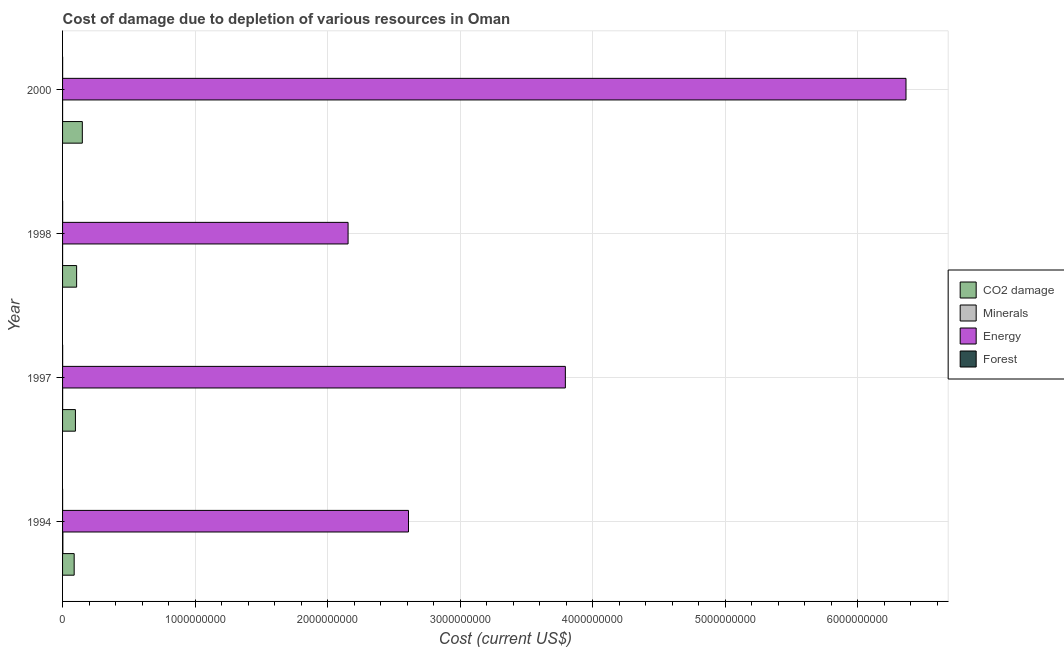How many groups of bars are there?
Make the answer very short. 4. Are the number of bars per tick equal to the number of legend labels?
Your answer should be compact. Yes. Are the number of bars on each tick of the Y-axis equal?
Provide a short and direct response. Yes. How many bars are there on the 3rd tick from the bottom?
Offer a very short reply. 4. In how many cases, is the number of bars for a given year not equal to the number of legend labels?
Ensure brevity in your answer.  0. What is the cost of damage due to depletion of minerals in 2000?
Keep it short and to the point. 4.51e+04. Across all years, what is the maximum cost of damage due to depletion of coal?
Provide a succinct answer. 1.49e+08. Across all years, what is the minimum cost of damage due to depletion of coal?
Provide a short and direct response. 8.76e+07. In which year was the cost of damage due to depletion of coal maximum?
Your answer should be compact. 2000. What is the total cost of damage due to depletion of minerals in the graph?
Give a very brief answer. 3.04e+06. What is the difference between the cost of damage due to depletion of minerals in 1997 and that in 2000?
Give a very brief answer. 4.32e+05. What is the difference between the cost of damage due to depletion of minerals in 2000 and the cost of damage due to depletion of coal in 1997?
Offer a very short reply. -9.70e+07. What is the average cost of damage due to depletion of forests per year?
Your answer should be compact. 4.68e+05. In the year 1994, what is the difference between the cost of damage due to depletion of energy and cost of damage due to depletion of forests?
Provide a succinct answer. 2.61e+09. What is the ratio of the cost of damage due to depletion of energy in 1997 to that in 1998?
Your response must be concise. 1.76. What is the difference between the highest and the second highest cost of damage due to depletion of energy?
Offer a very short reply. 2.57e+09. What is the difference between the highest and the lowest cost of damage due to depletion of forests?
Your answer should be compact. 1.61e+05. Is it the case that in every year, the sum of the cost of damage due to depletion of energy and cost of damage due to depletion of forests is greater than the sum of cost of damage due to depletion of minerals and cost of damage due to depletion of coal?
Your answer should be very brief. No. What does the 1st bar from the top in 1994 represents?
Provide a succinct answer. Forest. What does the 1st bar from the bottom in 1997 represents?
Your answer should be very brief. CO2 damage. Is it the case that in every year, the sum of the cost of damage due to depletion of coal and cost of damage due to depletion of minerals is greater than the cost of damage due to depletion of energy?
Provide a succinct answer. No. How many bars are there?
Ensure brevity in your answer.  16. Are all the bars in the graph horizontal?
Provide a succinct answer. Yes. How many years are there in the graph?
Your answer should be very brief. 4. What is the difference between two consecutive major ticks on the X-axis?
Keep it short and to the point. 1.00e+09. Are the values on the major ticks of X-axis written in scientific E-notation?
Make the answer very short. No. Does the graph contain any zero values?
Give a very brief answer. No. Does the graph contain grids?
Provide a short and direct response. Yes. How many legend labels are there?
Provide a short and direct response. 4. How are the legend labels stacked?
Keep it short and to the point. Vertical. What is the title of the graph?
Your response must be concise. Cost of damage due to depletion of various resources in Oman . Does "Secondary vocational" appear as one of the legend labels in the graph?
Keep it short and to the point. No. What is the label or title of the X-axis?
Provide a succinct answer. Cost (current US$). What is the Cost (current US$) of CO2 damage in 1994?
Ensure brevity in your answer.  8.76e+07. What is the Cost (current US$) of Minerals in 1994?
Make the answer very short. 2.30e+06. What is the Cost (current US$) of Energy in 1994?
Make the answer very short. 2.61e+09. What is the Cost (current US$) of Forest in 1994?
Your answer should be compact. 3.81e+05. What is the Cost (current US$) of CO2 damage in 1997?
Your response must be concise. 9.70e+07. What is the Cost (current US$) in Minerals in 1997?
Keep it short and to the point. 4.78e+05. What is the Cost (current US$) in Energy in 1997?
Provide a succinct answer. 3.79e+09. What is the Cost (current US$) of Forest in 1997?
Provide a succinct answer. 5.17e+05. What is the Cost (current US$) of CO2 damage in 1998?
Keep it short and to the point. 1.06e+08. What is the Cost (current US$) in Minerals in 1998?
Your answer should be very brief. 2.19e+05. What is the Cost (current US$) in Energy in 1998?
Offer a very short reply. 2.15e+09. What is the Cost (current US$) of Forest in 1998?
Provide a short and direct response. 5.42e+05. What is the Cost (current US$) of CO2 damage in 2000?
Your answer should be very brief. 1.49e+08. What is the Cost (current US$) of Minerals in 2000?
Offer a terse response. 4.51e+04. What is the Cost (current US$) of Energy in 2000?
Give a very brief answer. 6.36e+09. What is the Cost (current US$) in Forest in 2000?
Provide a succinct answer. 4.33e+05. Across all years, what is the maximum Cost (current US$) of CO2 damage?
Your answer should be compact. 1.49e+08. Across all years, what is the maximum Cost (current US$) in Minerals?
Offer a very short reply. 2.30e+06. Across all years, what is the maximum Cost (current US$) of Energy?
Your response must be concise. 6.36e+09. Across all years, what is the maximum Cost (current US$) of Forest?
Provide a short and direct response. 5.42e+05. Across all years, what is the minimum Cost (current US$) of CO2 damage?
Keep it short and to the point. 8.76e+07. Across all years, what is the minimum Cost (current US$) of Minerals?
Give a very brief answer. 4.51e+04. Across all years, what is the minimum Cost (current US$) of Energy?
Give a very brief answer. 2.15e+09. Across all years, what is the minimum Cost (current US$) in Forest?
Give a very brief answer. 3.81e+05. What is the total Cost (current US$) of CO2 damage in the graph?
Offer a very short reply. 4.40e+08. What is the total Cost (current US$) in Minerals in the graph?
Ensure brevity in your answer.  3.04e+06. What is the total Cost (current US$) of Energy in the graph?
Offer a very short reply. 1.49e+1. What is the total Cost (current US$) of Forest in the graph?
Your answer should be compact. 1.87e+06. What is the difference between the Cost (current US$) of CO2 damage in 1994 and that in 1997?
Your answer should be compact. -9.44e+06. What is the difference between the Cost (current US$) of Minerals in 1994 and that in 1997?
Provide a succinct answer. 1.82e+06. What is the difference between the Cost (current US$) of Energy in 1994 and that in 1997?
Your answer should be very brief. -1.18e+09. What is the difference between the Cost (current US$) of Forest in 1994 and that in 1997?
Your response must be concise. -1.36e+05. What is the difference between the Cost (current US$) of CO2 damage in 1994 and that in 1998?
Give a very brief answer. -1.85e+07. What is the difference between the Cost (current US$) of Minerals in 1994 and that in 1998?
Keep it short and to the point. 2.08e+06. What is the difference between the Cost (current US$) of Energy in 1994 and that in 1998?
Provide a short and direct response. 4.56e+08. What is the difference between the Cost (current US$) of Forest in 1994 and that in 1998?
Make the answer very short. -1.61e+05. What is the difference between the Cost (current US$) of CO2 damage in 1994 and that in 2000?
Provide a short and direct response. -6.16e+07. What is the difference between the Cost (current US$) in Minerals in 1994 and that in 2000?
Offer a very short reply. 2.25e+06. What is the difference between the Cost (current US$) of Energy in 1994 and that in 2000?
Offer a terse response. -3.75e+09. What is the difference between the Cost (current US$) of Forest in 1994 and that in 2000?
Your answer should be very brief. -5.16e+04. What is the difference between the Cost (current US$) in CO2 damage in 1997 and that in 1998?
Provide a succinct answer. -9.09e+06. What is the difference between the Cost (current US$) in Minerals in 1997 and that in 1998?
Provide a short and direct response. 2.59e+05. What is the difference between the Cost (current US$) of Energy in 1997 and that in 1998?
Your response must be concise. 1.64e+09. What is the difference between the Cost (current US$) in Forest in 1997 and that in 1998?
Offer a very short reply. -2.47e+04. What is the difference between the Cost (current US$) in CO2 damage in 1997 and that in 2000?
Your response must be concise. -5.21e+07. What is the difference between the Cost (current US$) of Minerals in 1997 and that in 2000?
Offer a very short reply. 4.32e+05. What is the difference between the Cost (current US$) in Energy in 1997 and that in 2000?
Offer a very short reply. -2.57e+09. What is the difference between the Cost (current US$) in Forest in 1997 and that in 2000?
Ensure brevity in your answer.  8.47e+04. What is the difference between the Cost (current US$) in CO2 damage in 1998 and that in 2000?
Make the answer very short. -4.30e+07. What is the difference between the Cost (current US$) in Minerals in 1998 and that in 2000?
Offer a terse response. 1.74e+05. What is the difference between the Cost (current US$) of Energy in 1998 and that in 2000?
Provide a succinct answer. -4.21e+09. What is the difference between the Cost (current US$) of Forest in 1998 and that in 2000?
Your answer should be very brief. 1.09e+05. What is the difference between the Cost (current US$) in CO2 damage in 1994 and the Cost (current US$) in Minerals in 1997?
Your response must be concise. 8.71e+07. What is the difference between the Cost (current US$) in CO2 damage in 1994 and the Cost (current US$) in Energy in 1997?
Keep it short and to the point. -3.71e+09. What is the difference between the Cost (current US$) of CO2 damage in 1994 and the Cost (current US$) of Forest in 1997?
Your answer should be very brief. 8.71e+07. What is the difference between the Cost (current US$) of Minerals in 1994 and the Cost (current US$) of Energy in 1997?
Ensure brevity in your answer.  -3.79e+09. What is the difference between the Cost (current US$) in Minerals in 1994 and the Cost (current US$) in Forest in 1997?
Give a very brief answer. 1.78e+06. What is the difference between the Cost (current US$) in Energy in 1994 and the Cost (current US$) in Forest in 1997?
Provide a succinct answer. 2.61e+09. What is the difference between the Cost (current US$) of CO2 damage in 1994 and the Cost (current US$) of Minerals in 1998?
Your response must be concise. 8.74e+07. What is the difference between the Cost (current US$) in CO2 damage in 1994 and the Cost (current US$) in Energy in 1998?
Your answer should be very brief. -2.07e+09. What is the difference between the Cost (current US$) of CO2 damage in 1994 and the Cost (current US$) of Forest in 1998?
Give a very brief answer. 8.70e+07. What is the difference between the Cost (current US$) of Minerals in 1994 and the Cost (current US$) of Energy in 1998?
Your answer should be very brief. -2.15e+09. What is the difference between the Cost (current US$) in Minerals in 1994 and the Cost (current US$) in Forest in 1998?
Ensure brevity in your answer.  1.76e+06. What is the difference between the Cost (current US$) in Energy in 1994 and the Cost (current US$) in Forest in 1998?
Make the answer very short. 2.61e+09. What is the difference between the Cost (current US$) of CO2 damage in 1994 and the Cost (current US$) of Minerals in 2000?
Ensure brevity in your answer.  8.75e+07. What is the difference between the Cost (current US$) in CO2 damage in 1994 and the Cost (current US$) in Energy in 2000?
Provide a succinct answer. -6.28e+09. What is the difference between the Cost (current US$) in CO2 damage in 1994 and the Cost (current US$) in Forest in 2000?
Offer a very short reply. 8.71e+07. What is the difference between the Cost (current US$) of Minerals in 1994 and the Cost (current US$) of Energy in 2000?
Your answer should be compact. -6.36e+09. What is the difference between the Cost (current US$) in Minerals in 1994 and the Cost (current US$) in Forest in 2000?
Your answer should be very brief. 1.87e+06. What is the difference between the Cost (current US$) in Energy in 1994 and the Cost (current US$) in Forest in 2000?
Provide a short and direct response. 2.61e+09. What is the difference between the Cost (current US$) in CO2 damage in 1997 and the Cost (current US$) in Minerals in 1998?
Provide a short and direct response. 9.68e+07. What is the difference between the Cost (current US$) in CO2 damage in 1997 and the Cost (current US$) in Energy in 1998?
Offer a very short reply. -2.06e+09. What is the difference between the Cost (current US$) of CO2 damage in 1997 and the Cost (current US$) of Forest in 1998?
Ensure brevity in your answer.  9.65e+07. What is the difference between the Cost (current US$) of Minerals in 1997 and the Cost (current US$) of Energy in 1998?
Your answer should be very brief. -2.15e+09. What is the difference between the Cost (current US$) in Minerals in 1997 and the Cost (current US$) in Forest in 1998?
Provide a short and direct response. -6.46e+04. What is the difference between the Cost (current US$) in Energy in 1997 and the Cost (current US$) in Forest in 1998?
Your answer should be compact. 3.79e+09. What is the difference between the Cost (current US$) in CO2 damage in 1997 and the Cost (current US$) in Minerals in 2000?
Your answer should be compact. 9.70e+07. What is the difference between the Cost (current US$) of CO2 damage in 1997 and the Cost (current US$) of Energy in 2000?
Give a very brief answer. -6.27e+09. What is the difference between the Cost (current US$) of CO2 damage in 1997 and the Cost (current US$) of Forest in 2000?
Offer a terse response. 9.66e+07. What is the difference between the Cost (current US$) in Minerals in 1997 and the Cost (current US$) in Energy in 2000?
Offer a very short reply. -6.36e+09. What is the difference between the Cost (current US$) of Minerals in 1997 and the Cost (current US$) of Forest in 2000?
Provide a short and direct response. 4.48e+04. What is the difference between the Cost (current US$) in Energy in 1997 and the Cost (current US$) in Forest in 2000?
Your answer should be very brief. 3.79e+09. What is the difference between the Cost (current US$) of CO2 damage in 1998 and the Cost (current US$) of Minerals in 2000?
Give a very brief answer. 1.06e+08. What is the difference between the Cost (current US$) of CO2 damage in 1998 and the Cost (current US$) of Energy in 2000?
Your response must be concise. -6.26e+09. What is the difference between the Cost (current US$) in CO2 damage in 1998 and the Cost (current US$) in Forest in 2000?
Offer a terse response. 1.06e+08. What is the difference between the Cost (current US$) in Minerals in 1998 and the Cost (current US$) in Energy in 2000?
Keep it short and to the point. -6.36e+09. What is the difference between the Cost (current US$) in Minerals in 1998 and the Cost (current US$) in Forest in 2000?
Provide a succinct answer. -2.14e+05. What is the difference between the Cost (current US$) in Energy in 1998 and the Cost (current US$) in Forest in 2000?
Make the answer very short. 2.15e+09. What is the average Cost (current US$) of CO2 damage per year?
Provide a short and direct response. 1.10e+08. What is the average Cost (current US$) of Minerals per year?
Your response must be concise. 7.60e+05. What is the average Cost (current US$) in Energy per year?
Offer a terse response. 3.73e+09. What is the average Cost (current US$) in Forest per year?
Provide a succinct answer. 4.68e+05. In the year 1994, what is the difference between the Cost (current US$) in CO2 damage and Cost (current US$) in Minerals?
Make the answer very short. 8.53e+07. In the year 1994, what is the difference between the Cost (current US$) in CO2 damage and Cost (current US$) in Energy?
Offer a very short reply. -2.52e+09. In the year 1994, what is the difference between the Cost (current US$) of CO2 damage and Cost (current US$) of Forest?
Your response must be concise. 8.72e+07. In the year 1994, what is the difference between the Cost (current US$) in Minerals and Cost (current US$) in Energy?
Keep it short and to the point. -2.61e+09. In the year 1994, what is the difference between the Cost (current US$) in Minerals and Cost (current US$) in Forest?
Your answer should be compact. 1.92e+06. In the year 1994, what is the difference between the Cost (current US$) of Energy and Cost (current US$) of Forest?
Make the answer very short. 2.61e+09. In the year 1997, what is the difference between the Cost (current US$) in CO2 damage and Cost (current US$) in Minerals?
Give a very brief answer. 9.65e+07. In the year 1997, what is the difference between the Cost (current US$) of CO2 damage and Cost (current US$) of Energy?
Offer a very short reply. -3.70e+09. In the year 1997, what is the difference between the Cost (current US$) in CO2 damage and Cost (current US$) in Forest?
Your answer should be very brief. 9.65e+07. In the year 1997, what is the difference between the Cost (current US$) in Minerals and Cost (current US$) in Energy?
Give a very brief answer. -3.79e+09. In the year 1997, what is the difference between the Cost (current US$) in Minerals and Cost (current US$) in Forest?
Your response must be concise. -3.99e+04. In the year 1997, what is the difference between the Cost (current US$) in Energy and Cost (current US$) in Forest?
Give a very brief answer. 3.79e+09. In the year 1998, what is the difference between the Cost (current US$) in CO2 damage and Cost (current US$) in Minerals?
Provide a short and direct response. 1.06e+08. In the year 1998, what is the difference between the Cost (current US$) of CO2 damage and Cost (current US$) of Energy?
Give a very brief answer. -2.05e+09. In the year 1998, what is the difference between the Cost (current US$) of CO2 damage and Cost (current US$) of Forest?
Your answer should be very brief. 1.06e+08. In the year 1998, what is the difference between the Cost (current US$) of Minerals and Cost (current US$) of Energy?
Your response must be concise. -2.15e+09. In the year 1998, what is the difference between the Cost (current US$) in Minerals and Cost (current US$) in Forest?
Keep it short and to the point. -3.23e+05. In the year 1998, what is the difference between the Cost (current US$) of Energy and Cost (current US$) of Forest?
Your answer should be compact. 2.15e+09. In the year 2000, what is the difference between the Cost (current US$) of CO2 damage and Cost (current US$) of Minerals?
Your response must be concise. 1.49e+08. In the year 2000, what is the difference between the Cost (current US$) of CO2 damage and Cost (current US$) of Energy?
Make the answer very short. -6.22e+09. In the year 2000, what is the difference between the Cost (current US$) in CO2 damage and Cost (current US$) in Forest?
Ensure brevity in your answer.  1.49e+08. In the year 2000, what is the difference between the Cost (current US$) in Minerals and Cost (current US$) in Energy?
Ensure brevity in your answer.  -6.36e+09. In the year 2000, what is the difference between the Cost (current US$) in Minerals and Cost (current US$) in Forest?
Provide a succinct answer. -3.88e+05. In the year 2000, what is the difference between the Cost (current US$) of Energy and Cost (current US$) of Forest?
Your answer should be compact. 6.36e+09. What is the ratio of the Cost (current US$) of CO2 damage in 1994 to that in 1997?
Provide a succinct answer. 0.9. What is the ratio of the Cost (current US$) in Minerals in 1994 to that in 1997?
Provide a short and direct response. 4.81. What is the ratio of the Cost (current US$) of Energy in 1994 to that in 1997?
Your answer should be compact. 0.69. What is the ratio of the Cost (current US$) of Forest in 1994 to that in 1997?
Your answer should be very brief. 0.74. What is the ratio of the Cost (current US$) in CO2 damage in 1994 to that in 1998?
Your answer should be very brief. 0.83. What is the ratio of the Cost (current US$) of Minerals in 1994 to that in 1998?
Your response must be concise. 10.5. What is the ratio of the Cost (current US$) of Energy in 1994 to that in 1998?
Your answer should be very brief. 1.21. What is the ratio of the Cost (current US$) in Forest in 1994 to that in 1998?
Provide a succinct answer. 0.7. What is the ratio of the Cost (current US$) of CO2 damage in 1994 to that in 2000?
Give a very brief answer. 0.59. What is the ratio of the Cost (current US$) of Minerals in 1994 to that in 2000?
Your answer should be compact. 50.95. What is the ratio of the Cost (current US$) of Energy in 1994 to that in 2000?
Make the answer very short. 0.41. What is the ratio of the Cost (current US$) in Forest in 1994 to that in 2000?
Your answer should be compact. 0.88. What is the ratio of the Cost (current US$) of CO2 damage in 1997 to that in 1998?
Provide a succinct answer. 0.91. What is the ratio of the Cost (current US$) in Minerals in 1997 to that in 1998?
Give a very brief answer. 2.18. What is the ratio of the Cost (current US$) of Energy in 1997 to that in 1998?
Your answer should be compact. 1.76. What is the ratio of the Cost (current US$) in Forest in 1997 to that in 1998?
Your response must be concise. 0.95. What is the ratio of the Cost (current US$) of CO2 damage in 1997 to that in 2000?
Offer a very short reply. 0.65. What is the ratio of the Cost (current US$) in Minerals in 1997 to that in 2000?
Make the answer very short. 10.58. What is the ratio of the Cost (current US$) of Energy in 1997 to that in 2000?
Offer a very short reply. 0.6. What is the ratio of the Cost (current US$) of Forest in 1997 to that in 2000?
Provide a short and direct response. 1.2. What is the ratio of the Cost (current US$) of CO2 damage in 1998 to that in 2000?
Your answer should be compact. 0.71. What is the ratio of the Cost (current US$) in Minerals in 1998 to that in 2000?
Ensure brevity in your answer.  4.85. What is the ratio of the Cost (current US$) in Energy in 1998 to that in 2000?
Your answer should be compact. 0.34. What is the ratio of the Cost (current US$) in Forest in 1998 to that in 2000?
Ensure brevity in your answer.  1.25. What is the difference between the highest and the second highest Cost (current US$) in CO2 damage?
Offer a terse response. 4.30e+07. What is the difference between the highest and the second highest Cost (current US$) of Minerals?
Provide a short and direct response. 1.82e+06. What is the difference between the highest and the second highest Cost (current US$) of Energy?
Make the answer very short. 2.57e+09. What is the difference between the highest and the second highest Cost (current US$) in Forest?
Provide a short and direct response. 2.47e+04. What is the difference between the highest and the lowest Cost (current US$) in CO2 damage?
Provide a succinct answer. 6.16e+07. What is the difference between the highest and the lowest Cost (current US$) in Minerals?
Provide a short and direct response. 2.25e+06. What is the difference between the highest and the lowest Cost (current US$) of Energy?
Make the answer very short. 4.21e+09. What is the difference between the highest and the lowest Cost (current US$) of Forest?
Offer a very short reply. 1.61e+05. 